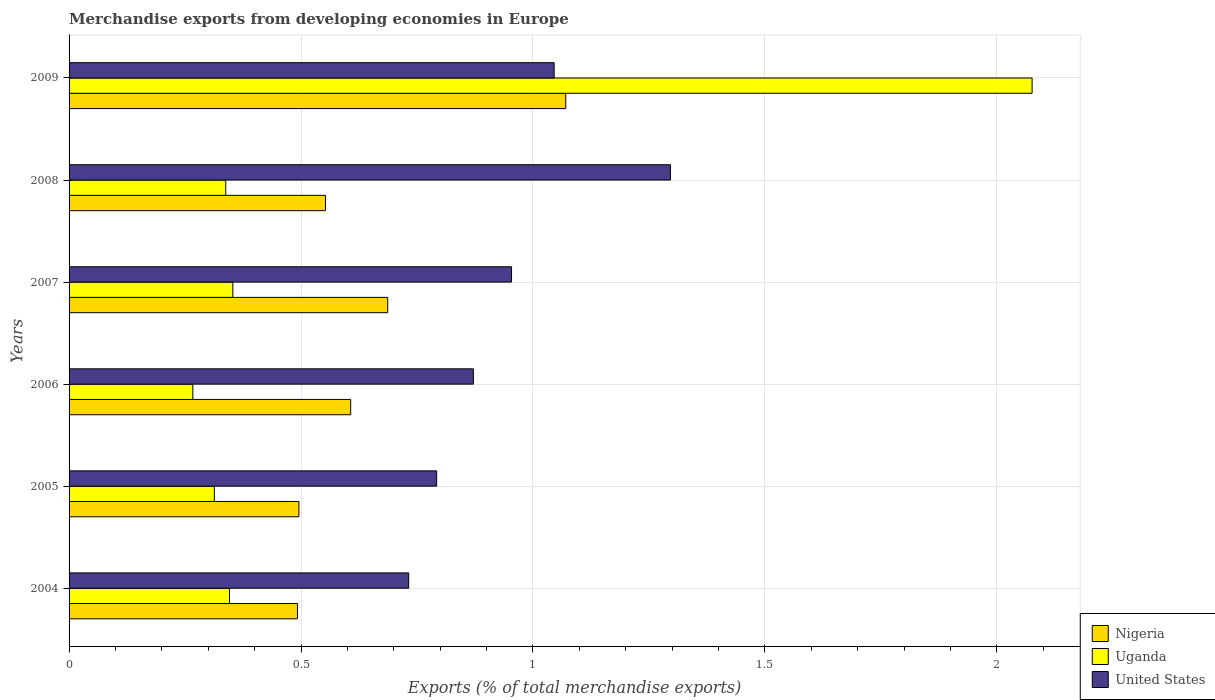Are the number of bars on each tick of the Y-axis equal?
Ensure brevity in your answer.  Yes. How many bars are there on the 1st tick from the top?
Give a very brief answer. 3. What is the percentage of total merchandise exports in United States in 2004?
Give a very brief answer. 0.73. Across all years, what is the maximum percentage of total merchandise exports in Nigeria?
Make the answer very short. 1.07. Across all years, what is the minimum percentage of total merchandise exports in Nigeria?
Provide a short and direct response. 0.49. In which year was the percentage of total merchandise exports in United States maximum?
Ensure brevity in your answer.  2008. What is the total percentage of total merchandise exports in Nigeria in the graph?
Keep it short and to the point. 3.91. What is the difference between the percentage of total merchandise exports in United States in 2005 and that in 2008?
Offer a terse response. -0.5. What is the difference between the percentage of total merchandise exports in United States in 2006 and the percentage of total merchandise exports in Nigeria in 2007?
Offer a terse response. 0.18. What is the average percentage of total merchandise exports in Nigeria per year?
Keep it short and to the point. 0.65. In the year 2005, what is the difference between the percentage of total merchandise exports in Nigeria and percentage of total merchandise exports in United States?
Your answer should be compact. -0.3. In how many years, is the percentage of total merchandise exports in Uganda greater than 0.4 %?
Keep it short and to the point. 1. What is the ratio of the percentage of total merchandise exports in Uganda in 2004 to that in 2006?
Offer a very short reply. 1.3. Is the percentage of total merchandise exports in United States in 2004 less than that in 2009?
Your answer should be compact. Yes. Is the difference between the percentage of total merchandise exports in Nigeria in 2007 and 2009 greater than the difference between the percentage of total merchandise exports in United States in 2007 and 2009?
Make the answer very short. No. What is the difference between the highest and the second highest percentage of total merchandise exports in Nigeria?
Offer a very short reply. 0.38. What is the difference between the highest and the lowest percentage of total merchandise exports in Nigeria?
Your answer should be compact. 0.58. Is the sum of the percentage of total merchandise exports in United States in 2004 and 2009 greater than the maximum percentage of total merchandise exports in Nigeria across all years?
Offer a very short reply. Yes. What does the 3rd bar from the top in 2004 represents?
Your answer should be compact. Nigeria. Are all the bars in the graph horizontal?
Keep it short and to the point. Yes. How many years are there in the graph?
Your response must be concise. 6. Does the graph contain any zero values?
Offer a terse response. No. Does the graph contain grids?
Your answer should be compact. Yes. Where does the legend appear in the graph?
Provide a succinct answer. Bottom right. What is the title of the graph?
Provide a succinct answer. Merchandise exports from developing economies in Europe. Does "Curacao" appear as one of the legend labels in the graph?
Offer a very short reply. No. What is the label or title of the X-axis?
Offer a terse response. Exports (% of total merchandise exports). What is the label or title of the Y-axis?
Your answer should be compact. Years. What is the Exports (% of total merchandise exports) in Nigeria in 2004?
Your response must be concise. 0.49. What is the Exports (% of total merchandise exports) in Uganda in 2004?
Provide a succinct answer. 0.35. What is the Exports (% of total merchandise exports) of United States in 2004?
Keep it short and to the point. 0.73. What is the Exports (% of total merchandise exports) in Nigeria in 2005?
Provide a short and direct response. 0.5. What is the Exports (% of total merchandise exports) of Uganda in 2005?
Ensure brevity in your answer.  0.31. What is the Exports (% of total merchandise exports) of United States in 2005?
Provide a succinct answer. 0.79. What is the Exports (% of total merchandise exports) of Nigeria in 2006?
Offer a terse response. 0.61. What is the Exports (% of total merchandise exports) of Uganda in 2006?
Your response must be concise. 0.27. What is the Exports (% of total merchandise exports) in United States in 2006?
Give a very brief answer. 0.87. What is the Exports (% of total merchandise exports) of Nigeria in 2007?
Your response must be concise. 0.69. What is the Exports (% of total merchandise exports) in Uganda in 2007?
Your answer should be compact. 0.35. What is the Exports (% of total merchandise exports) in United States in 2007?
Offer a terse response. 0.95. What is the Exports (% of total merchandise exports) of Nigeria in 2008?
Provide a short and direct response. 0.55. What is the Exports (% of total merchandise exports) in Uganda in 2008?
Ensure brevity in your answer.  0.34. What is the Exports (% of total merchandise exports) of United States in 2008?
Provide a succinct answer. 1.3. What is the Exports (% of total merchandise exports) in Nigeria in 2009?
Ensure brevity in your answer.  1.07. What is the Exports (% of total merchandise exports) of Uganda in 2009?
Ensure brevity in your answer.  2.08. What is the Exports (% of total merchandise exports) in United States in 2009?
Keep it short and to the point. 1.05. Across all years, what is the maximum Exports (% of total merchandise exports) in Nigeria?
Offer a terse response. 1.07. Across all years, what is the maximum Exports (% of total merchandise exports) in Uganda?
Offer a very short reply. 2.08. Across all years, what is the maximum Exports (% of total merchandise exports) of United States?
Offer a terse response. 1.3. Across all years, what is the minimum Exports (% of total merchandise exports) of Nigeria?
Offer a very short reply. 0.49. Across all years, what is the minimum Exports (% of total merchandise exports) in Uganda?
Provide a short and direct response. 0.27. Across all years, what is the minimum Exports (% of total merchandise exports) in United States?
Ensure brevity in your answer.  0.73. What is the total Exports (% of total merchandise exports) of Nigeria in the graph?
Your response must be concise. 3.91. What is the total Exports (% of total merchandise exports) in Uganda in the graph?
Your answer should be very brief. 3.69. What is the total Exports (% of total merchandise exports) of United States in the graph?
Give a very brief answer. 5.69. What is the difference between the Exports (% of total merchandise exports) in Nigeria in 2004 and that in 2005?
Ensure brevity in your answer.  -0. What is the difference between the Exports (% of total merchandise exports) in Uganda in 2004 and that in 2005?
Provide a succinct answer. 0.03. What is the difference between the Exports (% of total merchandise exports) in United States in 2004 and that in 2005?
Your answer should be very brief. -0.06. What is the difference between the Exports (% of total merchandise exports) of Nigeria in 2004 and that in 2006?
Your answer should be very brief. -0.11. What is the difference between the Exports (% of total merchandise exports) of Uganda in 2004 and that in 2006?
Provide a short and direct response. 0.08. What is the difference between the Exports (% of total merchandise exports) in United States in 2004 and that in 2006?
Ensure brevity in your answer.  -0.14. What is the difference between the Exports (% of total merchandise exports) in Nigeria in 2004 and that in 2007?
Offer a very short reply. -0.19. What is the difference between the Exports (% of total merchandise exports) in Uganda in 2004 and that in 2007?
Your answer should be compact. -0.01. What is the difference between the Exports (% of total merchandise exports) of United States in 2004 and that in 2007?
Keep it short and to the point. -0.22. What is the difference between the Exports (% of total merchandise exports) of Nigeria in 2004 and that in 2008?
Your response must be concise. -0.06. What is the difference between the Exports (% of total merchandise exports) in Uganda in 2004 and that in 2008?
Ensure brevity in your answer.  0.01. What is the difference between the Exports (% of total merchandise exports) in United States in 2004 and that in 2008?
Your answer should be very brief. -0.56. What is the difference between the Exports (% of total merchandise exports) in Nigeria in 2004 and that in 2009?
Offer a terse response. -0.58. What is the difference between the Exports (% of total merchandise exports) of Uganda in 2004 and that in 2009?
Give a very brief answer. -1.73. What is the difference between the Exports (% of total merchandise exports) in United States in 2004 and that in 2009?
Ensure brevity in your answer.  -0.31. What is the difference between the Exports (% of total merchandise exports) of Nigeria in 2005 and that in 2006?
Your answer should be compact. -0.11. What is the difference between the Exports (% of total merchandise exports) of Uganda in 2005 and that in 2006?
Offer a terse response. 0.05. What is the difference between the Exports (% of total merchandise exports) in United States in 2005 and that in 2006?
Offer a very short reply. -0.08. What is the difference between the Exports (% of total merchandise exports) of Nigeria in 2005 and that in 2007?
Ensure brevity in your answer.  -0.19. What is the difference between the Exports (% of total merchandise exports) of Uganda in 2005 and that in 2007?
Give a very brief answer. -0.04. What is the difference between the Exports (% of total merchandise exports) of United States in 2005 and that in 2007?
Offer a terse response. -0.16. What is the difference between the Exports (% of total merchandise exports) in Nigeria in 2005 and that in 2008?
Your response must be concise. -0.06. What is the difference between the Exports (% of total merchandise exports) of Uganda in 2005 and that in 2008?
Keep it short and to the point. -0.02. What is the difference between the Exports (% of total merchandise exports) of United States in 2005 and that in 2008?
Offer a very short reply. -0.5. What is the difference between the Exports (% of total merchandise exports) of Nigeria in 2005 and that in 2009?
Ensure brevity in your answer.  -0.58. What is the difference between the Exports (% of total merchandise exports) in Uganda in 2005 and that in 2009?
Keep it short and to the point. -1.76. What is the difference between the Exports (% of total merchandise exports) in United States in 2005 and that in 2009?
Give a very brief answer. -0.25. What is the difference between the Exports (% of total merchandise exports) in Nigeria in 2006 and that in 2007?
Provide a succinct answer. -0.08. What is the difference between the Exports (% of total merchandise exports) in Uganda in 2006 and that in 2007?
Offer a very short reply. -0.09. What is the difference between the Exports (% of total merchandise exports) of United States in 2006 and that in 2007?
Make the answer very short. -0.08. What is the difference between the Exports (% of total merchandise exports) of Nigeria in 2006 and that in 2008?
Offer a terse response. 0.05. What is the difference between the Exports (% of total merchandise exports) in Uganda in 2006 and that in 2008?
Ensure brevity in your answer.  -0.07. What is the difference between the Exports (% of total merchandise exports) of United States in 2006 and that in 2008?
Your response must be concise. -0.42. What is the difference between the Exports (% of total merchandise exports) of Nigeria in 2006 and that in 2009?
Ensure brevity in your answer.  -0.46. What is the difference between the Exports (% of total merchandise exports) of Uganda in 2006 and that in 2009?
Provide a succinct answer. -1.81. What is the difference between the Exports (% of total merchandise exports) of United States in 2006 and that in 2009?
Provide a short and direct response. -0.17. What is the difference between the Exports (% of total merchandise exports) in Nigeria in 2007 and that in 2008?
Give a very brief answer. 0.13. What is the difference between the Exports (% of total merchandise exports) of Uganda in 2007 and that in 2008?
Offer a terse response. 0.02. What is the difference between the Exports (% of total merchandise exports) of United States in 2007 and that in 2008?
Your response must be concise. -0.34. What is the difference between the Exports (% of total merchandise exports) of Nigeria in 2007 and that in 2009?
Ensure brevity in your answer.  -0.38. What is the difference between the Exports (% of total merchandise exports) in Uganda in 2007 and that in 2009?
Your answer should be very brief. -1.72. What is the difference between the Exports (% of total merchandise exports) of United States in 2007 and that in 2009?
Provide a succinct answer. -0.09. What is the difference between the Exports (% of total merchandise exports) of Nigeria in 2008 and that in 2009?
Keep it short and to the point. -0.52. What is the difference between the Exports (% of total merchandise exports) in Uganda in 2008 and that in 2009?
Offer a very short reply. -1.74. What is the difference between the Exports (% of total merchandise exports) of United States in 2008 and that in 2009?
Your answer should be very brief. 0.25. What is the difference between the Exports (% of total merchandise exports) in Nigeria in 2004 and the Exports (% of total merchandise exports) in Uganda in 2005?
Your response must be concise. 0.18. What is the difference between the Exports (% of total merchandise exports) in Nigeria in 2004 and the Exports (% of total merchandise exports) in United States in 2005?
Provide a short and direct response. -0.3. What is the difference between the Exports (% of total merchandise exports) of Uganda in 2004 and the Exports (% of total merchandise exports) of United States in 2005?
Your answer should be very brief. -0.45. What is the difference between the Exports (% of total merchandise exports) in Nigeria in 2004 and the Exports (% of total merchandise exports) in Uganda in 2006?
Give a very brief answer. 0.23. What is the difference between the Exports (% of total merchandise exports) of Nigeria in 2004 and the Exports (% of total merchandise exports) of United States in 2006?
Offer a terse response. -0.38. What is the difference between the Exports (% of total merchandise exports) of Uganda in 2004 and the Exports (% of total merchandise exports) of United States in 2006?
Provide a short and direct response. -0.53. What is the difference between the Exports (% of total merchandise exports) in Nigeria in 2004 and the Exports (% of total merchandise exports) in Uganda in 2007?
Provide a succinct answer. 0.14. What is the difference between the Exports (% of total merchandise exports) of Nigeria in 2004 and the Exports (% of total merchandise exports) of United States in 2007?
Offer a terse response. -0.46. What is the difference between the Exports (% of total merchandise exports) of Uganda in 2004 and the Exports (% of total merchandise exports) of United States in 2007?
Provide a short and direct response. -0.61. What is the difference between the Exports (% of total merchandise exports) of Nigeria in 2004 and the Exports (% of total merchandise exports) of Uganda in 2008?
Your answer should be very brief. 0.15. What is the difference between the Exports (% of total merchandise exports) of Nigeria in 2004 and the Exports (% of total merchandise exports) of United States in 2008?
Provide a succinct answer. -0.8. What is the difference between the Exports (% of total merchandise exports) of Uganda in 2004 and the Exports (% of total merchandise exports) of United States in 2008?
Your answer should be very brief. -0.95. What is the difference between the Exports (% of total merchandise exports) in Nigeria in 2004 and the Exports (% of total merchandise exports) in Uganda in 2009?
Your answer should be very brief. -1.58. What is the difference between the Exports (% of total merchandise exports) in Nigeria in 2004 and the Exports (% of total merchandise exports) in United States in 2009?
Give a very brief answer. -0.55. What is the difference between the Exports (% of total merchandise exports) of Uganda in 2004 and the Exports (% of total merchandise exports) of United States in 2009?
Your answer should be compact. -0.7. What is the difference between the Exports (% of total merchandise exports) in Nigeria in 2005 and the Exports (% of total merchandise exports) in Uganda in 2006?
Ensure brevity in your answer.  0.23. What is the difference between the Exports (% of total merchandise exports) in Nigeria in 2005 and the Exports (% of total merchandise exports) in United States in 2006?
Your answer should be compact. -0.38. What is the difference between the Exports (% of total merchandise exports) of Uganda in 2005 and the Exports (% of total merchandise exports) of United States in 2006?
Your answer should be very brief. -0.56. What is the difference between the Exports (% of total merchandise exports) of Nigeria in 2005 and the Exports (% of total merchandise exports) of Uganda in 2007?
Ensure brevity in your answer.  0.14. What is the difference between the Exports (% of total merchandise exports) of Nigeria in 2005 and the Exports (% of total merchandise exports) of United States in 2007?
Offer a terse response. -0.46. What is the difference between the Exports (% of total merchandise exports) of Uganda in 2005 and the Exports (% of total merchandise exports) of United States in 2007?
Offer a very short reply. -0.64. What is the difference between the Exports (% of total merchandise exports) in Nigeria in 2005 and the Exports (% of total merchandise exports) in Uganda in 2008?
Offer a very short reply. 0.16. What is the difference between the Exports (% of total merchandise exports) in Nigeria in 2005 and the Exports (% of total merchandise exports) in United States in 2008?
Provide a short and direct response. -0.8. What is the difference between the Exports (% of total merchandise exports) of Uganda in 2005 and the Exports (% of total merchandise exports) of United States in 2008?
Your response must be concise. -0.98. What is the difference between the Exports (% of total merchandise exports) in Nigeria in 2005 and the Exports (% of total merchandise exports) in Uganda in 2009?
Give a very brief answer. -1.58. What is the difference between the Exports (% of total merchandise exports) of Nigeria in 2005 and the Exports (% of total merchandise exports) of United States in 2009?
Your answer should be compact. -0.55. What is the difference between the Exports (% of total merchandise exports) in Uganda in 2005 and the Exports (% of total merchandise exports) in United States in 2009?
Your response must be concise. -0.73. What is the difference between the Exports (% of total merchandise exports) of Nigeria in 2006 and the Exports (% of total merchandise exports) of Uganda in 2007?
Provide a short and direct response. 0.25. What is the difference between the Exports (% of total merchandise exports) of Nigeria in 2006 and the Exports (% of total merchandise exports) of United States in 2007?
Ensure brevity in your answer.  -0.35. What is the difference between the Exports (% of total merchandise exports) of Uganda in 2006 and the Exports (% of total merchandise exports) of United States in 2007?
Make the answer very short. -0.69. What is the difference between the Exports (% of total merchandise exports) of Nigeria in 2006 and the Exports (% of total merchandise exports) of Uganda in 2008?
Your answer should be very brief. 0.27. What is the difference between the Exports (% of total merchandise exports) in Nigeria in 2006 and the Exports (% of total merchandise exports) in United States in 2008?
Your answer should be very brief. -0.69. What is the difference between the Exports (% of total merchandise exports) in Uganda in 2006 and the Exports (% of total merchandise exports) in United States in 2008?
Your response must be concise. -1.03. What is the difference between the Exports (% of total merchandise exports) in Nigeria in 2006 and the Exports (% of total merchandise exports) in Uganda in 2009?
Your answer should be compact. -1.47. What is the difference between the Exports (% of total merchandise exports) of Nigeria in 2006 and the Exports (% of total merchandise exports) of United States in 2009?
Give a very brief answer. -0.44. What is the difference between the Exports (% of total merchandise exports) in Uganda in 2006 and the Exports (% of total merchandise exports) in United States in 2009?
Your answer should be very brief. -0.78. What is the difference between the Exports (% of total merchandise exports) in Nigeria in 2007 and the Exports (% of total merchandise exports) in Uganda in 2008?
Give a very brief answer. 0.35. What is the difference between the Exports (% of total merchandise exports) in Nigeria in 2007 and the Exports (% of total merchandise exports) in United States in 2008?
Provide a short and direct response. -0.61. What is the difference between the Exports (% of total merchandise exports) of Uganda in 2007 and the Exports (% of total merchandise exports) of United States in 2008?
Give a very brief answer. -0.94. What is the difference between the Exports (% of total merchandise exports) of Nigeria in 2007 and the Exports (% of total merchandise exports) of Uganda in 2009?
Offer a very short reply. -1.39. What is the difference between the Exports (% of total merchandise exports) of Nigeria in 2007 and the Exports (% of total merchandise exports) of United States in 2009?
Keep it short and to the point. -0.36. What is the difference between the Exports (% of total merchandise exports) of Uganda in 2007 and the Exports (% of total merchandise exports) of United States in 2009?
Make the answer very short. -0.69. What is the difference between the Exports (% of total merchandise exports) of Nigeria in 2008 and the Exports (% of total merchandise exports) of Uganda in 2009?
Give a very brief answer. -1.52. What is the difference between the Exports (% of total merchandise exports) of Nigeria in 2008 and the Exports (% of total merchandise exports) of United States in 2009?
Keep it short and to the point. -0.49. What is the difference between the Exports (% of total merchandise exports) in Uganda in 2008 and the Exports (% of total merchandise exports) in United States in 2009?
Offer a very short reply. -0.71. What is the average Exports (% of total merchandise exports) of Nigeria per year?
Your answer should be compact. 0.65. What is the average Exports (% of total merchandise exports) of Uganda per year?
Your answer should be very brief. 0.62. What is the average Exports (% of total merchandise exports) of United States per year?
Make the answer very short. 0.95. In the year 2004, what is the difference between the Exports (% of total merchandise exports) of Nigeria and Exports (% of total merchandise exports) of Uganda?
Your answer should be very brief. 0.15. In the year 2004, what is the difference between the Exports (% of total merchandise exports) in Nigeria and Exports (% of total merchandise exports) in United States?
Your response must be concise. -0.24. In the year 2004, what is the difference between the Exports (% of total merchandise exports) of Uganda and Exports (% of total merchandise exports) of United States?
Offer a very short reply. -0.39. In the year 2005, what is the difference between the Exports (% of total merchandise exports) of Nigeria and Exports (% of total merchandise exports) of Uganda?
Ensure brevity in your answer.  0.18. In the year 2005, what is the difference between the Exports (% of total merchandise exports) in Nigeria and Exports (% of total merchandise exports) in United States?
Make the answer very short. -0.3. In the year 2005, what is the difference between the Exports (% of total merchandise exports) of Uganda and Exports (% of total merchandise exports) of United States?
Offer a terse response. -0.48. In the year 2006, what is the difference between the Exports (% of total merchandise exports) of Nigeria and Exports (% of total merchandise exports) of Uganda?
Your response must be concise. 0.34. In the year 2006, what is the difference between the Exports (% of total merchandise exports) in Nigeria and Exports (% of total merchandise exports) in United States?
Provide a short and direct response. -0.26. In the year 2006, what is the difference between the Exports (% of total merchandise exports) of Uganda and Exports (% of total merchandise exports) of United States?
Ensure brevity in your answer.  -0.6. In the year 2007, what is the difference between the Exports (% of total merchandise exports) in Nigeria and Exports (% of total merchandise exports) in Uganda?
Your response must be concise. 0.33. In the year 2007, what is the difference between the Exports (% of total merchandise exports) in Nigeria and Exports (% of total merchandise exports) in United States?
Give a very brief answer. -0.27. In the year 2007, what is the difference between the Exports (% of total merchandise exports) of Uganda and Exports (% of total merchandise exports) of United States?
Offer a very short reply. -0.6. In the year 2008, what is the difference between the Exports (% of total merchandise exports) of Nigeria and Exports (% of total merchandise exports) of Uganda?
Make the answer very short. 0.21. In the year 2008, what is the difference between the Exports (% of total merchandise exports) of Nigeria and Exports (% of total merchandise exports) of United States?
Provide a short and direct response. -0.74. In the year 2008, what is the difference between the Exports (% of total merchandise exports) in Uganda and Exports (% of total merchandise exports) in United States?
Provide a succinct answer. -0.96. In the year 2009, what is the difference between the Exports (% of total merchandise exports) of Nigeria and Exports (% of total merchandise exports) of Uganda?
Your answer should be very brief. -1.01. In the year 2009, what is the difference between the Exports (% of total merchandise exports) of Nigeria and Exports (% of total merchandise exports) of United States?
Make the answer very short. 0.03. In the year 2009, what is the difference between the Exports (% of total merchandise exports) of Uganda and Exports (% of total merchandise exports) of United States?
Ensure brevity in your answer.  1.03. What is the ratio of the Exports (% of total merchandise exports) of Nigeria in 2004 to that in 2005?
Your answer should be compact. 0.99. What is the ratio of the Exports (% of total merchandise exports) of Uganda in 2004 to that in 2005?
Offer a very short reply. 1.1. What is the ratio of the Exports (% of total merchandise exports) of United States in 2004 to that in 2005?
Make the answer very short. 0.92. What is the ratio of the Exports (% of total merchandise exports) in Nigeria in 2004 to that in 2006?
Give a very brief answer. 0.81. What is the ratio of the Exports (% of total merchandise exports) of Uganda in 2004 to that in 2006?
Provide a short and direct response. 1.3. What is the ratio of the Exports (% of total merchandise exports) of United States in 2004 to that in 2006?
Offer a terse response. 0.84. What is the ratio of the Exports (% of total merchandise exports) of Nigeria in 2004 to that in 2007?
Make the answer very short. 0.72. What is the ratio of the Exports (% of total merchandise exports) of Uganda in 2004 to that in 2007?
Your answer should be very brief. 0.98. What is the ratio of the Exports (% of total merchandise exports) in United States in 2004 to that in 2007?
Ensure brevity in your answer.  0.77. What is the ratio of the Exports (% of total merchandise exports) of Nigeria in 2004 to that in 2008?
Ensure brevity in your answer.  0.89. What is the ratio of the Exports (% of total merchandise exports) of Uganda in 2004 to that in 2008?
Offer a terse response. 1.02. What is the ratio of the Exports (% of total merchandise exports) of United States in 2004 to that in 2008?
Give a very brief answer. 0.56. What is the ratio of the Exports (% of total merchandise exports) in Nigeria in 2004 to that in 2009?
Keep it short and to the point. 0.46. What is the ratio of the Exports (% of total merchandise exports) in Uganda in 2004 to that in 2009?
Offer a terse response. 0.17. What is the ratio of the Exports (% of total merchandise exports) of United States in 2004 to that in 2009?
Provide a short and direct response. 0.7. What is the ratio of the Exports (% of total merchandise exports) of Nigeria in 2005 to that in 2006?
Give a very brief answer. 0.82. What is the ratio of the Exports (% of total merchandise exports) of Uganda in 2005 to that in 2006?
Give a very brief answer. 1.17. What is the ratio of the Exports (% of total merchandise exports) of United States in 2005 to that in 2006?
Keep it short and to the point. 0.91. What is the ratio of the Exports (% of total merchandise exports) of Nigeria in 2005 to that in 2007?
Ensure brevity in your answer.  0.72. What is the ratio of the Exports (% of total merchandise exports) of Uganda in 2005 to that in 2007?
Keep it short and to the point. 0.89. What is the ratio of the Exports (% of total merchandise exports) of United States in 2005 to that in 2007?
Offer a terse response. 0.83. What is the ratio of the Exports (% of total merchandise exports) in Nigeria in 2005 to that in 2008?
Offer a very short reply. 0.9. What is the ratio of the Exports (% of total merchandise exports) of Uganda in 2005 to that in 2008?
Keep it short and to the point. 0.93. What is the ratio of the Exports (% of total merchandise exports) of United States in 2005 to that in 2008?
Offer a terse response. 0.61. What is the ratio of the Exports (% of total merchandise exports) in Nigeria in 2005 to that in 2009?
Your answer should be compact. 0.46. What is the ratio of the Exports (% of total merchandise exports) in Uganda in 2005 to that in 2009?
Offer a very short reply. 0.15. What is the ratio of the Exports (% of total merchandise exports) of United States in 2005 to that in 2009?
Give a very brief answer. 0.76. What is the ratio of the Exports (% of total merchandise exports) in Nigeria in 2006 to that in 2007?
Keep it short and to the point. 0.88. What is the ratio of the Exports (% of total merchandise exports) in Uganda in 2006 to that in 2007?
Your answer should be very brief. 0.76. What is the ratio of the Exports (% of total merchandise exports) of United States in 2006 to that in 2007?
Your answer should be compact. 0.91. What is the ratio of the Exports (% of total merchandise exports) in Nigeria in 2006 to that in 2008?
Ensure brevity in your answer.  1.1. What is the ratio of the Exports (% of total merchandise exports) of Uganda in 2006 to that in 2008?
Keep it short and to the point. 0.79. What is the ratio of the Exports (% of total merchandise exports) of United States in 2006 to that in 2008?
Provide a succinct answer. 0.67. What is the ratio of the Exports (% of total merchandise exports) of Nigeria in 2006 to that in 2009?
Give a very brief answer. 0.57. What is the ratio of the Exports (% of total merchandise exports) of Uganda in 2006 to that in 2009?
Provide a succinct answer. 0.13. What is the ratio of the Exports (% of total merchandise exports) of United States in 2006 to that in 2009?
Your response must be concise. 0.83. What is the ratio of the Exports (% of total merchandise exports) of Nigeria in 2007 to that in 2008?
Keep it short and to the point. 1.24. What is the ratio of the Exports (% of total merchandise exports) in Uganda in 2007 to that in 2008?
Keep it short and to the point. 1.05. What is the ratio of the Exports (% of total merchandise exports) in United States in 2007 to that in 2008?
Ensure brevity in your answer.  0.74. What is the ratio of the Exports (% of total merchandise exports) of Nigeria in 2007 to that in 2009?
Offer a terse response. 0.64. What is the ratio of the Exports (% of total merchandise exports) of Uganda in 2007 to that in 2009?
Give a very brief answer. 0.17. What is the ratio of the Exports (% of total merchandise exports) in United States in 2007 to that in 2009?
Your answer should be compact. 0.91. What is the ratio of the Exports (% of total merchandise exports) in Nigeria in 2008 to that in 2009?
Make the answer very short. 0.52. What is the ratio of the Exports (% of total merchandise exports) in Uganda in 2008 to that in 2009?
Your answer should be very brief. 0.16. What is the ratio of the Exports (% of total merchandise exports) in United States in 2008 to that in 2009?
Your response must be concise. 1.24. What is the difference between the highest and the second highest Exports (% of total merchandise exports) of Nigeria?
Give a very brief answer. 0.38. What is the difference between the highest and the second highest Exports (% of total merchandise exports) in Uganda?
Offer a terse response. 1.72. What is the difference between the highest and the second highest Exports (% of total merchandise exports) in United States?
Make the answer very short. 0.25. What is the difference between the highest and the lowest Exports (% of total merchandise exports) in Nigeria?
Provide a short and direct response. 0.58. What is the difference between the highest and the lowest Exports (% of total merchandise exports) in Uganda?
Provide a succinct answer. 1.81. What is the difference between the highest and the lowest Exports (% of total merchandise exports) in United States?
Your answer should be very brief. 0.56. 